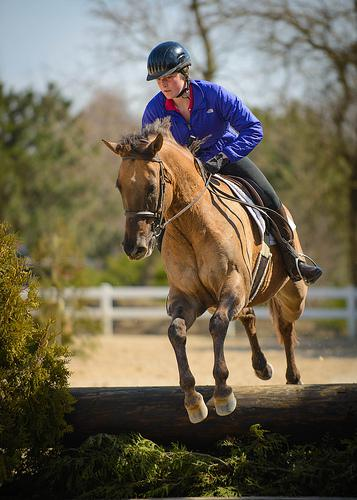Question: what color shirt is the rider wearing?
Choices:
A. Black.
B. Tan.
C. Brown.
D. Blue.
Answer with the letter. Answer: D Question: how does the rider have her feet?
Choices:
A. On the pedals.
B. In stirrups.
C. At her side.
D. Folded under her.
Answer with the letter. Answer: B Question: where is the log?
Choices:
A. On the truck.
B. In the woods.
C. Under the horse.
D. At the lumber mill.
Answer with the letter. Answer: C Question: what color is the rider's boots?
Choices:
A. Black.
B. Brown.
C. Tan.
D. Red.
Answer with the letter. Answer: A 